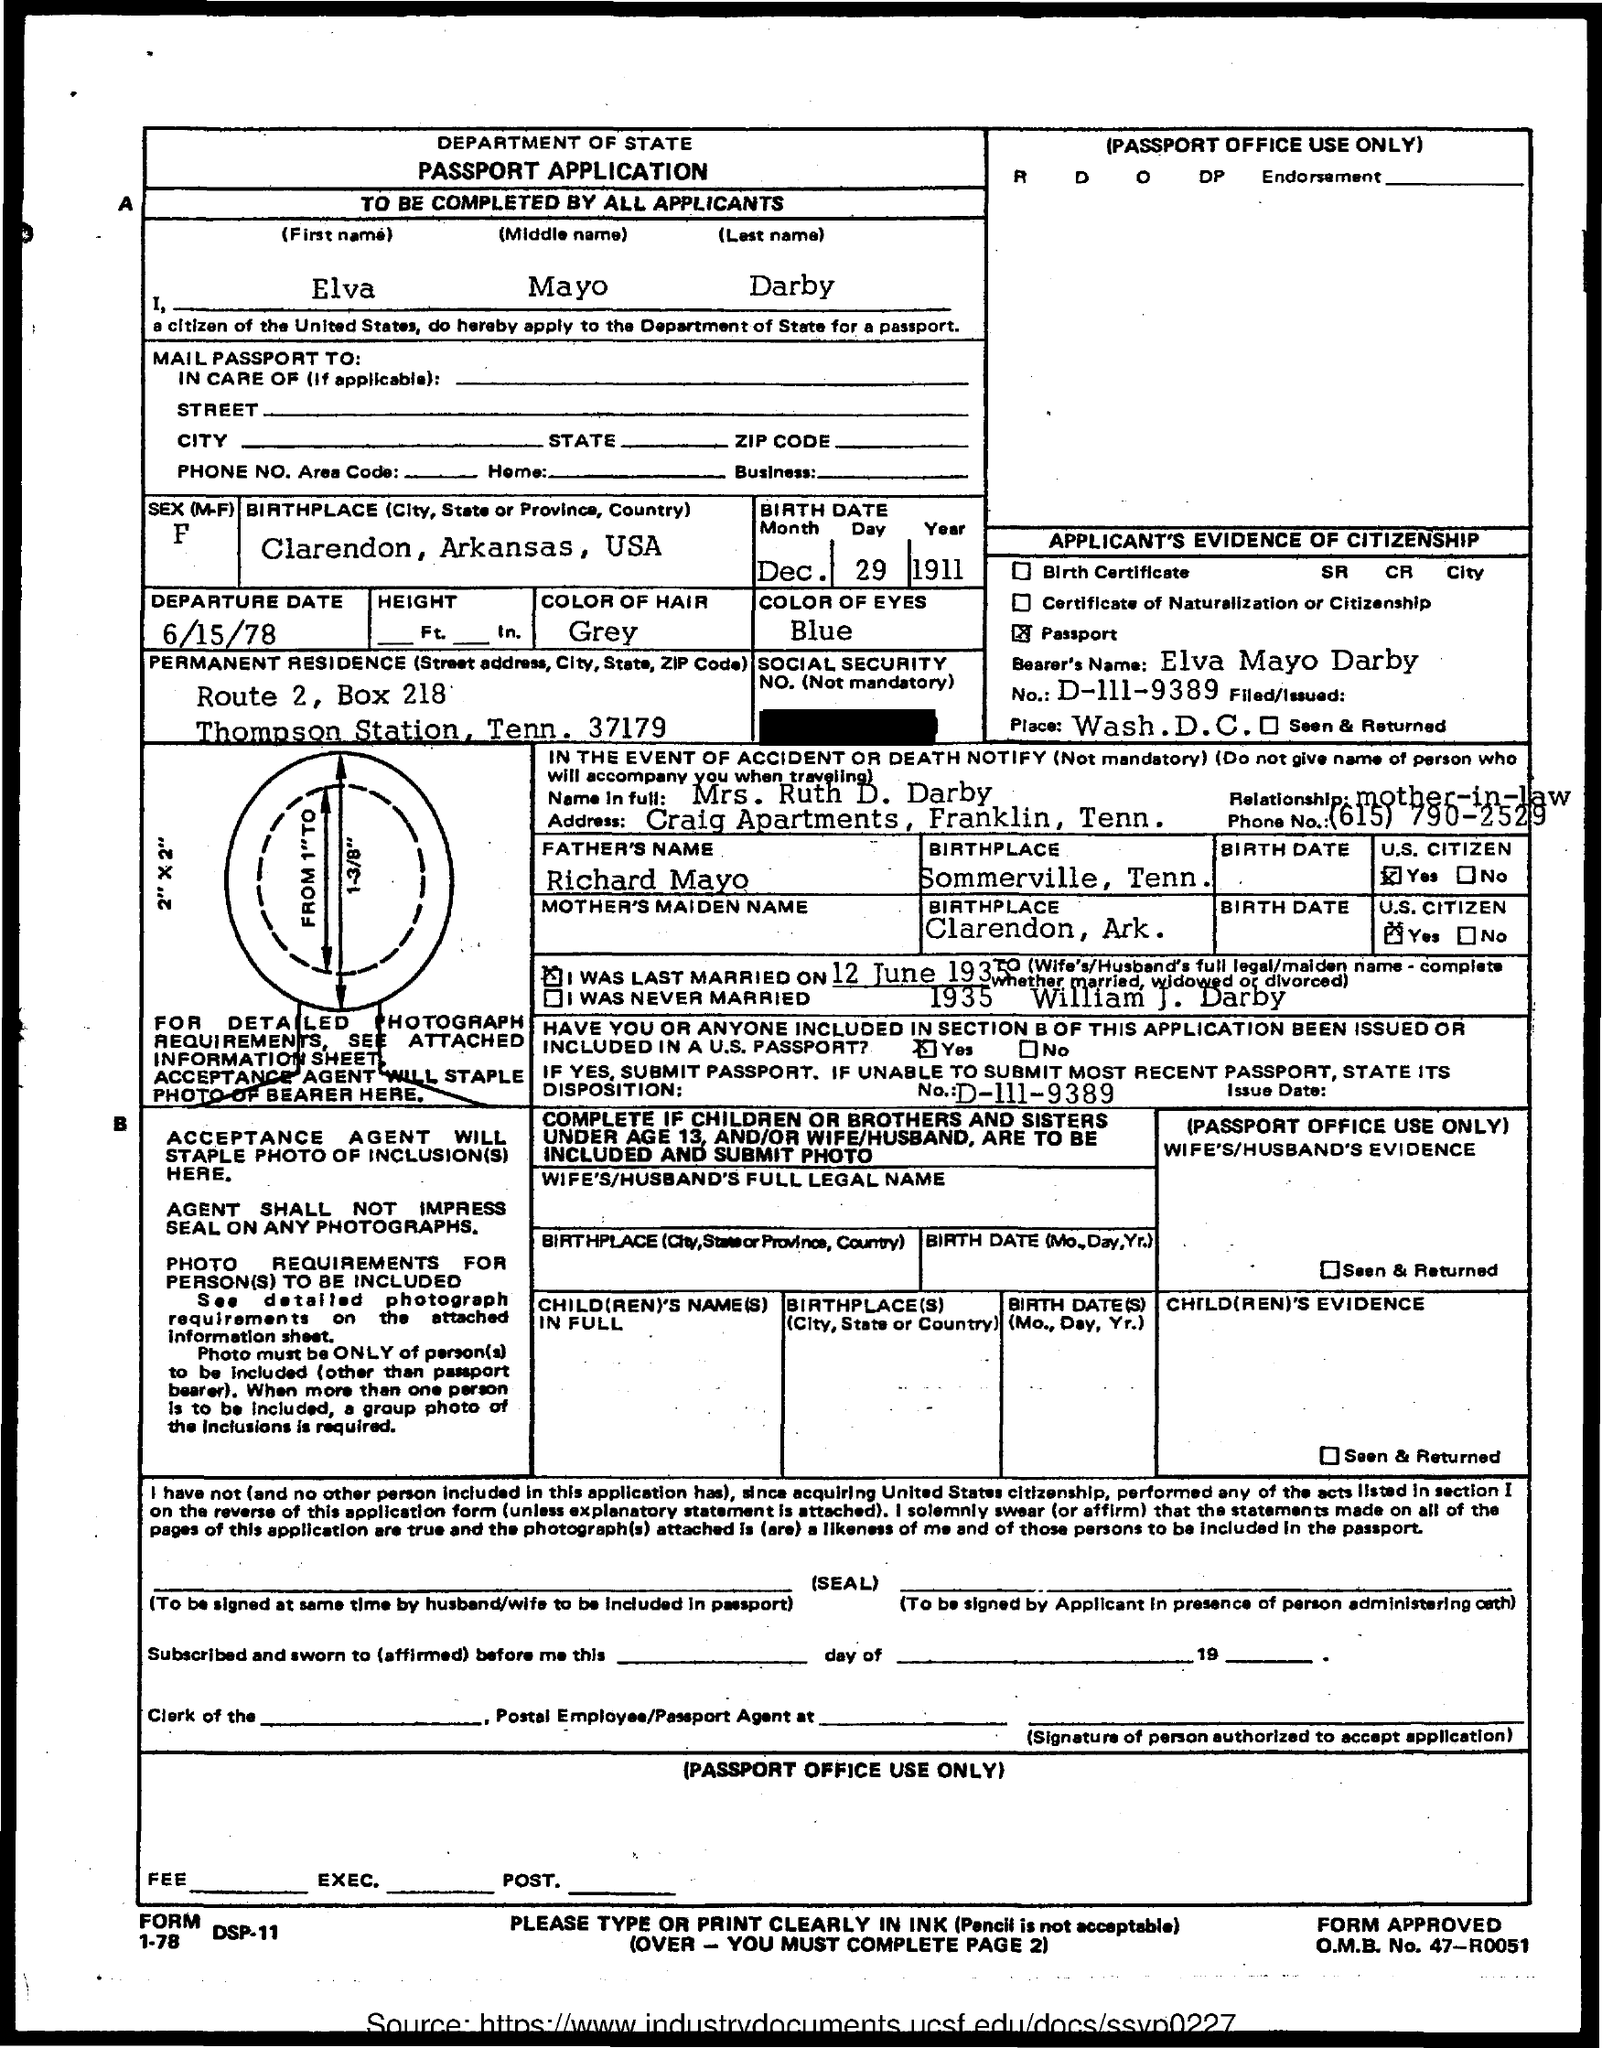Give some essential details in this illustration. Elva Mayo Darby was born in Clarendon, Arkansas, United States of America. The first name of the applicant is Elva. Elva Mayo Darby's father is Richard Mayo. The birthplace of Richard Mayo is Sommerville, Tennessee. Elva Mayo Darby was born on December 29, 1911. 